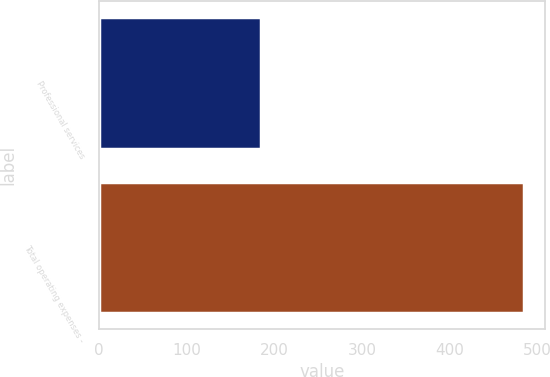Convert chart to OTSL. <chart><loc_0><loc_0><loc_500><loc_500><bar_chart><fcel>Professional services<fcel>Total operating expenses -<nl><fcel>184<fcel>484<nl></chart> 